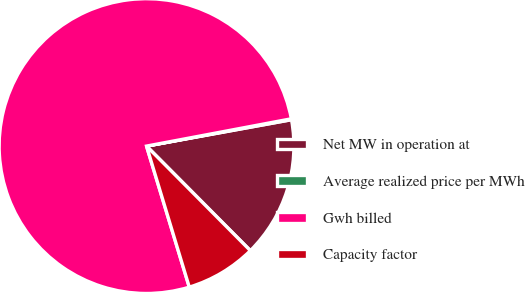Convert chart. <chart><loc_0><loc_0><loc_500><loc_500><pie_chart><fcel>Net MW in operation at<fcel>Average realized price per MWh<fcel>Gwh billed<fcel>Capacity factor<nl><fcel>15.42%<fcel>0.1%<fcel>76.72%<fcel>7.76%<nl></chart> 